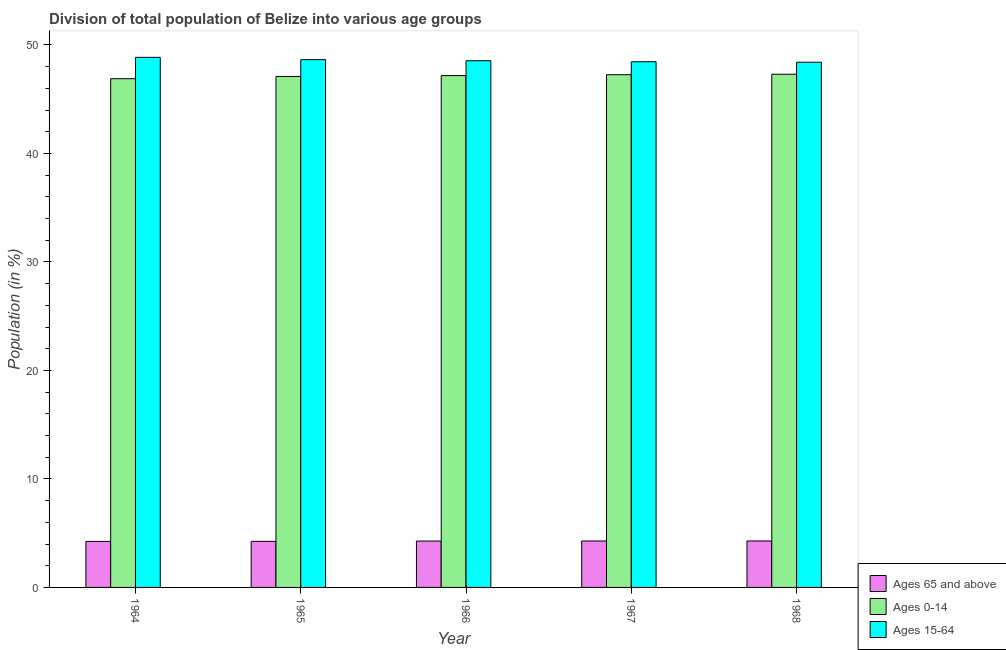How many different coloured bars are there?
Keep it short and to the point. 3. How many groups of bars are there?
Offer a terse response. 5. Are the number of bars per tick equal to the number of legend labels?
Give a very brief answer. Yes. Are the number of bars on each tick of the X-axis equal?
Offer a very short reply. Yes. How many bars are there on the 4th tick from the right?
Your response must be concise. 3. What is the label of the 4th group of bars from the left?
Your answer should be very brief. 1967. What is the percentage of population within the age-group 15-64 in 1964?
Keep it short and to the point. 48.86. Across all years, what is the maximum percentage of population within the age-group 0-14?
Offer a terse response. 47.31. Across all years, what is the minimum percentage of population within the age-group 15-64?
Offer a very short reply. 48.41. In which year was the percentage of population within the age-group of 65 and above maximum?
Provide a short and direct response. 1968. In which year was the percentage of population within the age-group 15-64 minimum?
Your answer should be compact. 1968. What is the total percentage of population within the age-group 0-14 in the graph?
Your answer should be very brief. 235.74. What is the difference between the percentage of population within the age-group of 65 and above in 1965 and that in 1966?
Keep it short and to the point. -0.02. What is the difference between the percentage of population within the age-group of 65 and above in 1967 and the percentage of population within the age-group 15-64 in 1964?
Offer a very short reply. 0.04. What is the average percentage of population within the age-group 0-14 per year?
Provide a short and direct response. 47.15. In how many years, is the percentage of population within the age-group of 65 and above greater than 40 %?
Keep it short and to the point. 0. What is the ratio of the percentage of population within the age-group 15-64 in 1965 to that in 1967?
Provide a short and direct response. 1. Is the percentage of population within the age-group of 65 and above in 1965 less than that in 1966?
Provide a succinct answer. Yes. Is the difference between the percentage of population within the age-group of 65 and above in 1964 and 1965 greater than the difference between the percentage of population within the age-group 15-64 in 1964 and 1965?
Offer a very short reply. No. What is the difference between the highest and the second highest percentage of population within the age-group of 65 and above?
Offer a very short reply. 0. What is the difference between the highest and the lowest percentage of population within the age-group 0-14?
Make the answer very short. 0.41. In how many years, is the percentage of population within the age-group 0-14 greater than the average percentage of population within the age-group 0-14 taken over all years?
Your answer should be very brief. 3. What does the 1st bar from the left in 1965 represents?
Offer a terse response. Ages 65 and above. What does the 2nd bar from the right in 1966 represents?
Your answer should be very brief. Ages 0-14. Is it the case that in every year, the sum of the percentage of population within the age-group of 65 and above and percentage of population within the age-group 0-14 is greater than the percentage of population within the age-group 15-64?
Give a very brief answer. Yes. How many bars are there?
Give a very brief answer. 15. Does the graph contain any zero values?
Offer a terse response. No. How are the legend labels stacked?
Make the answer very short. Vertical. What is the title of the graph?
Provide a succinct answer. Division of total population of Belize into various age groups
. Does "Primary education" appear as one of the legend labels in the graph?
Your response must be concise. No. What is the label or title of the X-axis?
Ensure brevity in your answer.  Year. What is the label or title of the Y-axis?
Your response must be concise. Population (in %). What is the Population (in %) of Ages 65 and above in 1964?
Offer a terse response. 4.24. What is the Population (in %) of Ages 0-14 in 1964?
Offer a very short reply. 46.89. What is the Population (in %) in Ages 15-64 in 1964?
Give a very brief answer. 48.86. What is the Population (in %) in Ages 65 and above in 1965?
Provide a succinct answer. 4.25. What is the Population (in %) in Ages 0-14 in 1965?
Your answer should be compact. 47.1. What is the Population (in %) of Ages 15-64 in 1965?
Provide a short and direct response. 48.65. What is the Population (in %) in Ages 65 and above in 1966?
Give a very brief answer. 4.27. What is the Population (in %) of Ages 0-14 in 1966?
Offer a very short reply. 47.18. What is the Population (in %) of Ages 15-64 in 1966?
Give a very brief answer. 48.55. What is the Population (in %) in Ages 65 and above in 1967?
Provide a short and direct response. 4.28. What is the Population (in %) in Ages 0-14 in 1967?
Provide a succinct answer. 47.26. What is the Population (in %) of Ages 15-64 in 1967?
Give a very brief answer. 48.46. What is the Population (in %) of Ages 65 and above in 1968?
Give a very brief answer. 4.28. What is the Population (in %) in Ages 0-14 in 1968?
Offer a terse response. 47.31. What is the Population (in %) of Ages 15-64 in 1968?
Provide a succinct answer. 48.41. Across all years, what is the maximum Population (in %) in Ages 65 and above?
Your answer should be very brief. 4.28. Across all years, what is the maximum Population (in %) of Ages 0-14?
Your response must be concise. 47.31. Across all years, what is the maximum Population (in %) of Ages 15-64?
Your answer should be very brief. 48.86. Across all years, what is the minimum Population (in %) of Ages 65 and above?
Make the answer very short. 4.24. Across all years, what is the minimum Population (in %) of Ages 0-14?
Your answer should be very brief. 46.89. Across all years, what is the minimum Population (in %) of Ages 15-64?
Keep it short and to the point. 48.41. What is the total Population (in %) of Ages 65 and above in the graph?
Your answer should be very brief. 21.32. What is the total Population (in %) in Ages 0-14 in the graph?
Your answer should be compact. 235.74. What is the total Population (in %) of Ages 15-64 in the graph?
Your response must be concise. 242.93. What is the difference between the Population (in %) in Ages 65 and above in 1964 and that in 1965?
Offer a terse response. -0. What is the difference between the Population (in %) of Ages 0-14 in 1964 and that in 1965?
Make the answer very short. -0.21. What is the difference between the Population (in %) in Ages 15-64 in 1964 and that in 1965?
Your answer should be compact. 0.21. What is the difference between the Population (in %) in Ages 65 and above in 1964 and that in 1966?
Give a very brief answer. -0.03. What is the difference between the Population (in %) in Ages 0-14 in 1964 and that in 1966?
Keep it short and to the point. -0.29. What is the difference between the Population (in %) in Ages 15-64 in 1964 and that in 1966?
Your response must be concise. 0.31. What is the difference between the Population (in %) of Ages 65 and above in 1964 and that in 1967?
Your response must be concise. -0.04. What is the difference between the Population (in %) of Ages 0-14 in 1964 and that in 1967?
Provide a short and direct response. -0.37. What is the difference between the Population (in %) of Ages 15-64 in 1964 and that in 1967?
Your response must be concise. 0.41. What is the difference between the Population (in %) of Ages 65 and above in 1964 and that in 1968?
Offer a terse response. -0.04. What is the difference between the Population (in %) of Ages 0-14 in 1964 and that in 1968?
Your answer should be compact. -0.41. What is the difference between the Population (in %) of Ages 15-64 in 1964 and that in 1968?
Offer a terse response. 0.45. What is the difference between the Population (in %) of Ages 65 and above in 1965 and that in 1966?
Your response must be concise. -0.02. What is the difference between the Population (in %) in Ages 0-14 in 1965 and that in 1966?
Your response must be concise. -0.08. What is the difference between the Population (in %) in Ages 15-64 in 1965 and that in 1966?
Your answer should be compact. 0.1. What is the difference between the Population (in %) in Ages 65 and above in 1965 and that in 1967?
Keep it short and to the point. -0.03. What is the difference between the Population (in %) of Ages 0-14 in 1965 and that in 1967?
Make the answer very short. -0.16. What is the difference between the Population (in %) of Ages 15-64 in 1965 and that in 1967?
Keep it short and to the point. 0.19. What is the difference between the Population (in %) of Ages 65 and above in 1965 and that in 1968?
Provide a short and direct response. -0.04. What is the difference between the Population (in %) in Ages 0-14 in 1965 and that in 1968?
Offer a very short reply. -0.2. What is the difference between the Population (in %) in Ages 15-64 in 1965 and that in 1968?
Your answer should be very brief. 0.24. What is the difference between the Population (in %) in Ages 65 and above in 1966 and that in 1967?
Provide a short and direct response. -0.01. What is the difference between the Population (in %) of Ages 0-14 in 1966 and that in 1967?
Provide a succinct answer. -0.08. What is the difference between the Population (in %) in Ages 15-64 in 1966 and that in 1967?
Offer a terse response. 0.09. What is the difference between the Population (in %) of Ages 65 and above in 1966 and that in 1968?
Offer a very short reply. -0.01. What is the difference between the Population (in %) of Ages 0-14 in 1966 and that in 1968?
Your answer should be very brief. -0.12. What is the difference between the Population (in %) of Ages 15-64 in 1966 and that in 1968?
Your answer should be compact. 0.14. What is the difference between the Population (in %) in Ages 65 and above in 1967 and that in 1968?
Your answer should be compact. -0. What is the difference between the Population (in %) in Ages 0-14 in 1967 and that in 1968?
Your answer should be very brief. -0.04. What is the difference between the Population (in %) of Ages 15-64 in 1967 and that in 1968?
Offer a terse response. 0.04. What is the difference between the Population (in %) of Ages 65 and above in 1964 and the Population (in %) of Ages 0-14 in 1965?
Offer a very short reply. -42.86. What is the difference between the Population (in %) of Ages 65 and above in 1964 and the Population (in %) of Ages 15-64 in 1965?
Make the answer very short. -44.41. What is the difference between the Population (in %) of Ages 0-14 in 1964 and the Population (in %) of Ages 15-64 in 1965?
Offer a very short reply. -1.76. What is the difference between the Population (in %) of Ages 65 and above in 1964 and the Population (in %) of Ages 0-14 in 1966?
Ensure brevity in your answer.  -42.94. What is the difference between the Population (in %) of Ages 65 and above in 1964 and the Population (in %) of Ages 15-64 in 1966?
Offer a terse response. -44.3. What is the difference between the Population (in %) of Ages 0-14 in 1964 and the Population (in %) of Ages 15-64 in 1966?
Provide a short and direct response. -1.66. What is the difference between the Population (in %) of Ages 65 and above in 1964 and the Population (in %) of Ages 0-14 in 1967?
Your answer should be compact. -43.02. What is the difference between the Population (in %) of Ages 65 and above in 1964 and the Population (in %) of Ages 15-64 in 1967?
Make the answer very short. -44.21. What is the difference between the Population (in %) in Ages 0-14 in 1964 and the Population (in %) in Ages 15-64 in 1967?
Your answer should be compact. -1.56. What is the difference between the Population (in %) in Ages 65 and above in 1964 and the Population (in %) in Ages 0-14 in 1968?
Make the answer very short. -43.06. What is the difference between the Population (in %) in Ages 65 and above in 1964 and the Population (in %) in Ages 15-64 in 1968?
Provide a succinct answer. -44.17. What is the difference between the Population (in %) in Ages 0-14 in 1964 and the Population (in %) in Ages 15-64 in 1968?
Give a very brief answer. -1.52. What is the difference between the Population (in %) in Ages 65 and above in 1965 and the Population (in %) in Ages 0-14 in 1966?
Keep it short and to the point. -42.93. What is the difference between the Population (in %) of Ages 65 and above in 1965 and the Population (in %) of Ages 15-64 in 1966?
Offer a very short reply. -44.3. What is the difference between the Population (in %) in Ages 0-14 in 1965 and the Population (in %) in Ages 15-64 in 1966?
Offer a very short reply. -1.45. What is the difference between the Population (in %) in Ages 65 and above in 1965 and the Population (in %) in Ages 0-14 in 1967?
Give a very brief answer. -43.02. What is the difference between the Population (in %) of Ages 65 and above in 1965 and the Population (in %) of Ages 15-64 in 1967?
Make the answer very short. -44.21. What is the difference between the Population (in %) in Ages 0-14 in 1965 and the Population (in %) in Ages 15-64 in 1967?
Your answer should be very brief. -1.36. What is the difference between the Population (in %) in Ages 65 and above in 1965 and the Population (in %) in Ages 0-14 in 1968?
Offer a very short reply. -43.06. What is the difference between the Population (in %) of Ages 65 and above in 1965 and the Population (in %) of Ages 15-64 in 1968?
Make the answer very short. -44.17. What is the difference between the Population (in %) in Ages 0-14 in 1965 and the Population (in %) in Ages 15-64 in 1968?
Provide a succinct answer. -1.31. What is the difference between the Population (in %) in Ages 65 and above in 1966 and the Population (in %) in Ages 0-14 in 1967?
Give a very brief answer. -42.99. What is the difference between the Population (in %) in Ages 65 and above in 1966 and the Population (in %) in Ages 15-64 in 1967?
Keep it short and to the point. -44.19. What is the difference between the Population (in %) of Ages 0-14 in 1966 and the Population (in %) of Ages 15-64 in 1967?
Provide a succinct answer. -1.28. What is the difference between the Population (in %) in Ages 65 and above in 1966 and the Population (in %) in Ages 0-14 in 1968?
Give a very brief answer. -43.03. What is the difference between the Population (in %) in Ages 65 and above in 1966 and the Population (in %) in Ages 15-64 in 1968?
Ensure brevity in your answer.  -44.14. What is the difference between the Population (in %) in Ages 0-14 in 1966 and the Population (in %) in Ages 15-64 in 1968?
Provide a short and direct response. -1.23. What is the difference between the Population (in %) of Ages 65 and above in 1967 and the Population (in %) of Ages 0-14 in 1968?
Ensure brevity in your answer.  -43.02. What is the difference between the Population (in %) of Ages 65 and above in 1967 and the Population (in %) of Ages 15-64 in 1968?
Your response must be concise. -44.13. What is the difference between the Population (in %) in Ages 0-14 in 1967 and the Population (in %) in Ages 15-64 in 1968?
Your response must be concise. -1.15. What is the average Population (in %) of Ages 65 and above per year?
Offer a terse response. 4.26. What is the average Population (in %) of Ages 0-14 per year?
Your response must be concise. 47.15. What is the average Population (in %) in Ages 15-64 per year?
Your answer should be very brief. 48.59. In the year 1964, what is the difference between the Population (in %) in Ages 65 and above and Population (in %) in Ages 0-14?
Offer a very short reply. -42.65. In the year 1964, what is the difference between the Population (in %) in Ages 65 and above and Population (in %) in Ages 15-64?
Offer a very short reply. -44.62. In the year 1964, what is the difference between the Population (in %) in Ages 0-14 and Population (in %) in Ages 15-64?
Your answer should be compact. -1.97. In the year 1965, what is the difference between the Population (in %) of Ages 65 and above and Population (in %) of Ages 0-14?
Your answer should be very brief. -42.85. In the year 1965, what is the difference between the Population (in %) in Ages 65 and above and Population (in %) in Ages 15-64?
Provide a short and direct response. -44.41. In the year 1965, what is the difference between the Population (in %) in Ages 0-14 and Population (in %) in Ages 15-64?
Keep it short and to the point. -1.55. In the year 1966, what is the difference between the Population (in %) of Ages 65 and above and Population (in %) of Ages 0-14?
Ensure brevity in your answer.  -42.91. In the year 1966, what is the difference between the Population (in %) in Ages 65 and above and Population (in %) in Ages 15-64?
Your answer should be very brief. -44.28. In the year 1966, what is the difference between the Population (in %) in Ages 0-14 and Population (in %) in Ages 15-64?
Your answer should be compact. -1.37. In the year 1967, what is the difference between the Population (in %) of Ages 65 and above and Population (in %) of Ages 0-14?
Your answer should be compact. -42.98. In the year 1967, what is the difference between the Population (in %) of Ages 65 and above and Population (in %) of Ages 15-64?
Offer a terse response. -44.18. In the year 1967, what is the difference between the Population (in %) in Ages 0-14 and Population (in %) in Ages 15-64?
Make the answer very short. -1.2. In the year 1968, what is the difference between the Population (in %) of Ages 65 and above and Population (in %) of Ages 0-14?
Your response must be concise. -43.02. In the year 1968, what is the difference between the Population (in %) of Ages 65 and above and Population (in %) of Ages 15-64?
Offer a terse response. -44.13. In the year 1968, what is the difference between the Population (in %) of Ages 0-14 and Population (in %) of Ages 15-64?
Your response must be concise. -1.11. What is the ratio of the Population (in %) in Ages 65 and above in 1964 to that in 1966?
Provide a succinct answer. 0.99. What is the ratio of the Population (in %) of Ages 15-64 in 1964 to that in 1967?
Offer a very short reply. 1.01. What is the ratio of the Population (in %) in Ages 0-14 in 1964 to that in 1968?
Give a very brief answer. 0.99. What is the ratio of the Population (in %) of Ages 15-64 in 1964 to that in 1968?
Offer a terse response. 1.01. What is the ratio of the Population (in %) of Ages 65 and above in 1965 to that in 1966?
Keep it short and to the point. 0.99. What is the ratio of the Population (in %) in Ages 65 and above in 1965 to that in 1967?
Provide a succinct answer. 0.99. What is the ratio of the Population (in %) in Ages 65 and above in 1965 to that in 1968?
Give a very brief answer. 0.99. What is the ratio of the Population (in %) in Ages 15-64 in 1965 to that in 1968?
Offer a very short reply. 1. What is the ratio of the Population (in %) in Ages 65 and above in 1966 to that in 1967?
Your answer should be very brief. 1. What is the ratio of the Population (in %) of Ages 0-14 in 1966 to that in 1967?
Your answer should be very brief. 1. What is the ratio of the Population (in %) of Ages 15-64 in 1966 to that in 1967?
Provide a succinct answer. 1. What is the ratio of the Population (in %) of Ages 0-14 in 1966 to that in 1968?
Your answer should be compact. 1. What is the ratio of the Population (in %) of Ages 65 and above in 1967 to that in 1968?
Offer a very short reply. 1. What is the ratio of the Population (in %) of Ages 15-64 in 1967 to that in 1968?
Offer a very short reply. 1. What is the difference between the highest and the second highest Population (in %) of Ages 65 and above?
Your answer should be very brief. 0. What is the difference between the highest and the second highest Population (in %) of Ages 0-14?
Your answer should be compact. 0.04. What is the difference between the highest and the second highest Population (in %) in Ages 15-64?
Offer a terse response. 0.21. What is the difference between the highest and the lowest Population (in %) in Ages 65 and above?
Provide a succinct answer. 0.04. What is the difference between the highest and the lowest Population (in %) in Ages 0-14?
Your answer should be compact. 0.41. What is the difference between the highest and the lowest Population (in %) of Ages 15-64?
Keep it short and to the point. 0.45. 